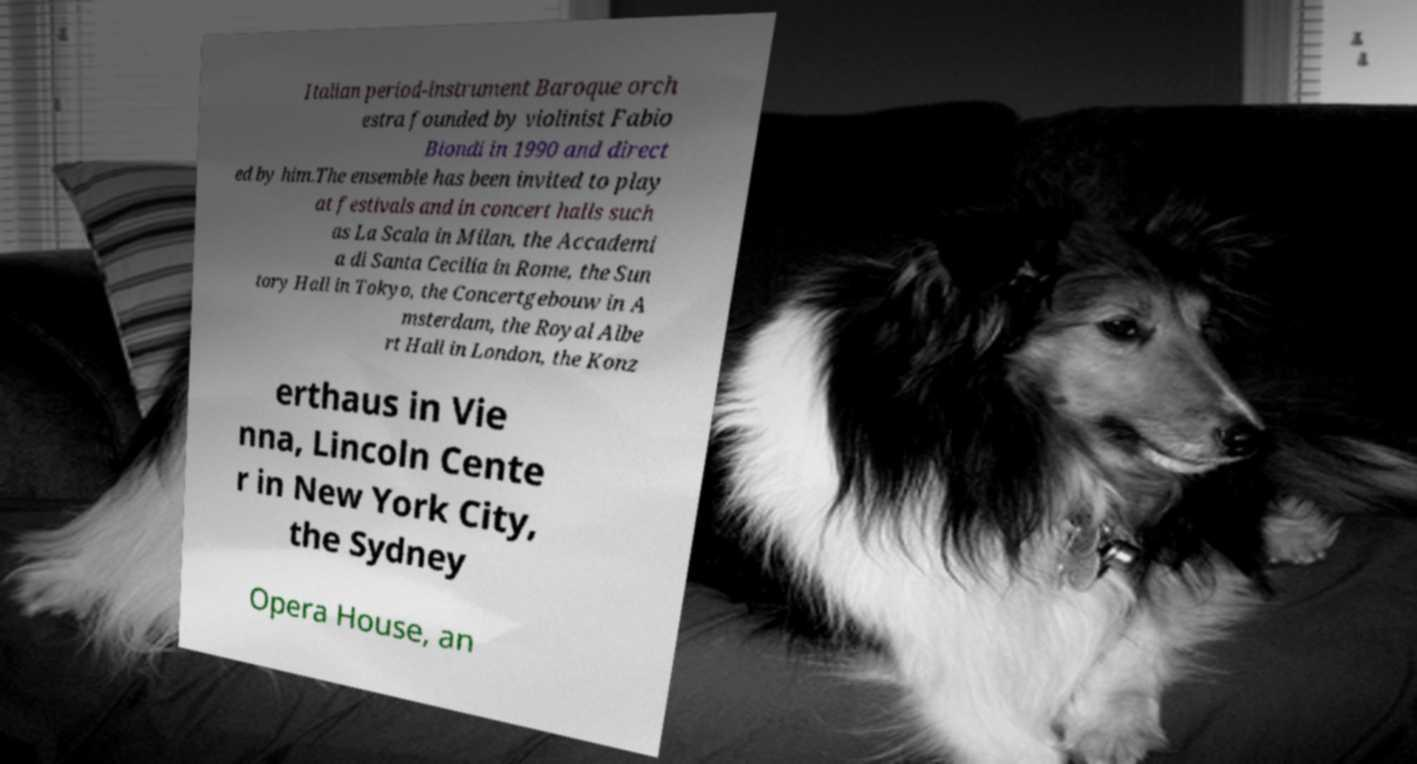Please identify and transcribe the text found in this image. Italian period-instrument Baroque orch estra founded by violinist Fabio Biondi in 1990 and direct ed by him.The ensemble has been invited to play at festivals and in concert halls such as La Scala in Milan, the Accademi a di Santa Cecilia in Rome, the Sun tory Hall in Tokyo, the Concertgebouw in A msterdam, the Royal Albe rt Hall in London, the Konz erthaus in Vie nna, Lincoln Cente r in New York City, the Sydney Opera House, an 